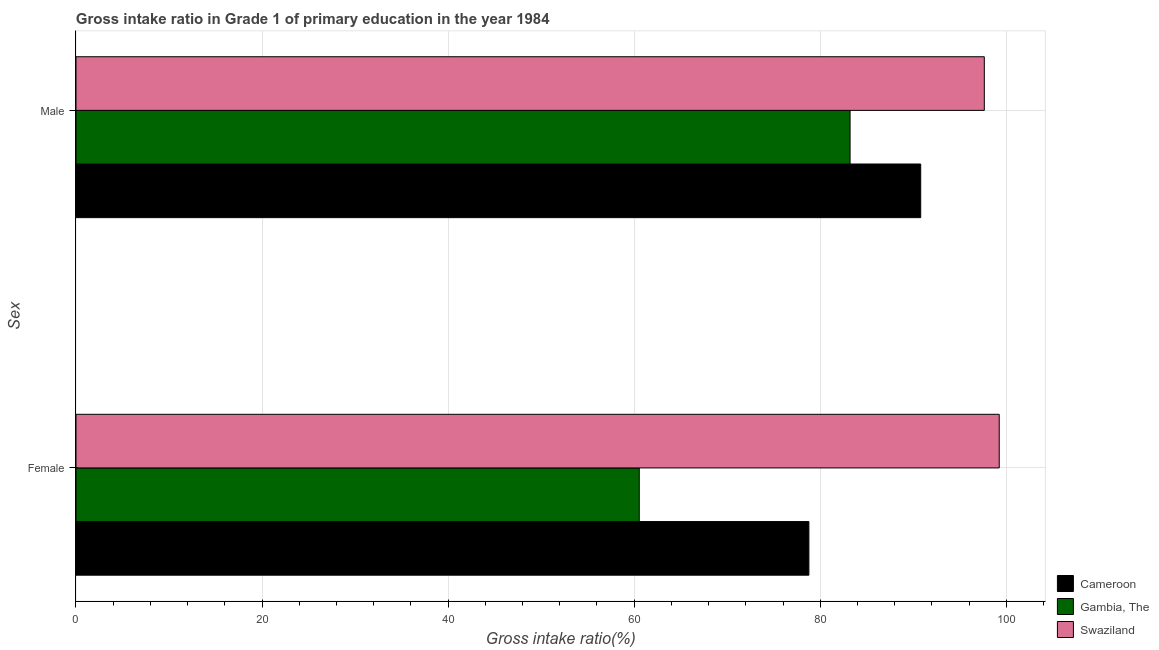Are the number of bars per tick equal to the number of legend labels?
Provide a short and direct response. Yes. Are the number of bars on each tick of the Y-axis equal?
Offer a very short reply. Yes. What is the gross intake ratio(female) in Swaziland?
Provide a short and direct response. 99.24. Across all countries, what is the maximum gross intake ratio(female)?
Provide a succinct answer. 99.24. Across all countries, what is the minimum gross intake ratio(male)?
Make the answer very short. 83.21. In which country was the gross intake ratio(female) maximum?
Keep it short and to the point. Swaziland. In which country was the gross intake ratio(male) minimum?
Offer a terse response. Gambia, The. What is the total gross intake ratio(male) in the graph?
Ensure brevity in your answer.  271.65. What is the difference between the gross intake ratio(male) in Gambia, The and that in Cameroon?
Offer a very short reply. -7.59. What is the difference between the gross intake ratio(male) in Cameroon and the gross intake ratio(female) in Swaziland?
Your response must be concise. -8.44. What is the average gross intake ratio(female) per country?
Your answer should be compact. 79.53. What is the difference between the gross intake ratio(female) and gross intake ratio(male) in Swaziland?
Keep it short and to the point. 1.6. What is the ratio of the gross intake ratio(male) in Cameroon to that in Swaziland?
Provide a succinct answer. 0.93. Is the gross intake ratio(male) in Cameroon less than that in Swaziland?
Give a very brief answer. Yes. In how many countries, is the gross intake ratio(female) greater than the average gross intake ratio(female) taken over all countries?
Provide a short and direct response. 1. What does the 3rd bar from the top in Female represents?
Offer a terse response. Cameroon. What does the 3rd bar from the bottom in Female represents?
Ensure brevity in your answer.  Swaziland. How many bars are there?
Provide a short and direct response. 6. Are all the bars in the graph horizontal?
Offer a very short reply. Yes. How many countries are there in the graph?
Keep it short and to the point. 3. Does the graph contain any zero values?
Provide a succinct answer. No. How many legend labels are there?
Ensure brevity in your answer.  3. How are the legend labels stacked?
Keep it short and to the point. Vertical. What is the title of the graph?
Ensure brevity in your answer.  Gross intake ratio in Grade 1 of primary education in the year 1984. Does "Middle income" appear as one of the legend labels in the graph?
Make the answer very short. No. What is the label or title of the X-axis?
Provide a short and direct response. Gross intake ratio(%). What is the label or title of the Y-axis?
Make the answer very short. Sex. What is the Gross intake ratio(%) of Cameroon in Female?
Keep it short and to the point. 78.78. What is the Gross intake ratio(%) of Gambia, The in Female?
Give a very brief answer. 60.55. What is the Gross intake ratio(%) of Swaziland in Female?
Keep it short and to the point. 99.24. What is the Gross intake ratio(%) of Cameroon in Male?
Your answer should be compact. 90.8. What is the Gross intake ratio(%) of Gambia, The in Male?
Your answer should be compact. 83.21. What is the Gross intake ratio(%) of Swaziland in Male?
Provide a succinct answer. 97.64. Across all Sex, what is the maximum Gross intake ratio(%) in Cameroon?
Provide a short and direct response. 90.8. Across all Sex, what is the maximum Gross intake ratio(%) in Gambia, The?
Make the answer very short. 83.21. Across all Sex, what is the maximum Gross intake ratio(%) of Swaziland?
Offer a very short reply. 99.24. Across all Sex, what is the minimum Gross intake ratio(%) of Cameroon?
Your answer should be compact. 78.78. Across all Sex, what is the minimum Gross intake ratio(%) in Gambia, The?
Your answer should be compact. 60.55. Across all Sex, what is the minimum Gross intake ratio(%) in Swaziland?
Offer a terse response. 97.64. What is the total Gross intake ratio(%) in Cameroon in the graph?
Provide a short and direct response. 169.59. What is the total Gross intake ratio(%) in Gambia, The in the graph?
Ensure brevity in your answer.  143.76. What is the total Gross intake ratio(%) in Swaziland in the graph?
Your response must be concise. 196.89. What is the difference between the Gross intake ratio(%) in Cameroon in Female and that in Male?
Make the answer very short. -12.02. What is the difference between the Gross intake ratio(%) of Gambia, The in Female and that in Male?
Your answer should be compact. -22.66. What is the difference between the Gross intake ratio(%) of Swaziland in Female and that in Male?
Your answer should be very brief. 1.6. What is the difference between the Gross intake ratio(%) of Cameroon in Female and the Gross intake ratio(%) of Gambia, The in Male?
Keep it short and to the point. -4.43. What is the difference between the Gross intake ratio(%) of Cameroon in Female and the Gross intake ratio(%) of Swaziland in Male?
Your answer should be very brief. -18.86. What is the difference between the Gross intake ratio(%) of Gambia, The in Female and the Gross intake ratio(%) of Swaziland in Male?
Provide a succinct answer. -37.09. What is the average Gross intake ratio(%) of Cameroon per Sex?
Offer a very short reply. 84.79. What is the average Gross intake ratio(%) of Gambia, The per Sex?
Make the answer very short. 71.88. What is the average Gross intake ratio(%) in Swaziland per Sex?
Provide a succinct answer. 98.44. What is the difference between the Gross intake ratio(%) in Cameroon and Gross intake ratio(%) in Gambia, The in Female?
Make the answer very short. 18.23. What is the difference between the Gross intake ratio(%) in Cameroon and Gross intake ratio(%) in Swaziland in Female?
Ensure brevity in your answer.  -20.46. What is the difference between the Gross intake ratio(%) of Gambia, The and Gross intake ratio(%) of Swaziland in Female?
Provide a short and direct response. -38.7. What is the difference between the Gross intake ratio(%) in Cameroon and Gross intake ratio(%) in Gambia, The in Male?
Make the answer very short. 7.59. What is the difference between the Gross intake ratio(%) in Cameroon and Gross intake ratio(%) in Swaziland in Male?
Your answer should be very brief. -6.84. What is the difference between the Gross intake ratio(%) of Gambia, The and Gross intake ratio(%) of Swaziland in Male?
Your answer should be compact. -14.43. What is the ratio of the Gross intake ratio(%) of Cameroon in Female to that in Male?
Give a very brief answer. 0.87. What is the ratio of the Gross intake ratio(%) of Gambia, The in Female to that in Male?
Make the answer very short. 0.73. What is the ratio of the Gross intake ratio(%) in Swaziland in Female to that in Male?
Give a very brief answer. 1.02. What is the difference between the highest and the second highest Gross intake ratio(%) in Cameroon?
Offer a terse response. 12.02. What is the difference between the highest and the second highest Gross intake ratio(%) in Gambia, The?
Provide a succinct answer. 22.66. What is the difference between the highest and the second highest Gross intake ratio(%) in Swaziland?
Your answer should be compact. 1.6. What is the difference between the highest and the lowest Gross intake ratio(%) in Cameroon?
Make the answer very short. 12.02. What is the difference between the highest and the lowest Gross intake ratio(%) of Gambia, The?
Offer a terse response. 22.66. What is the difference between the highest and the lowest Gross intake ratio(%) of Swaziland?
Give a very brief answer. 1.6. 